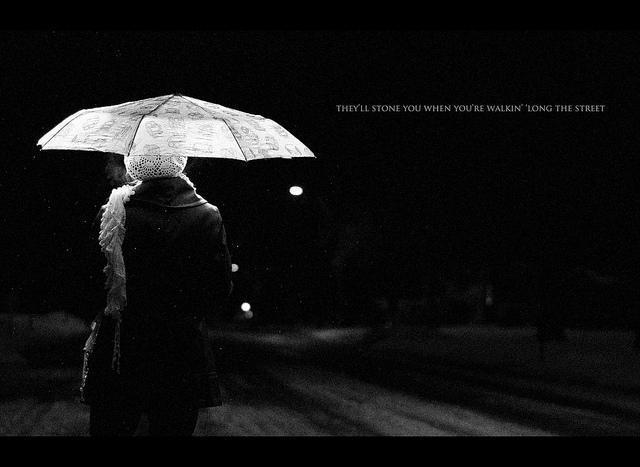How many train tracks are shown in the photo?
Give a very brief answer. 0. 